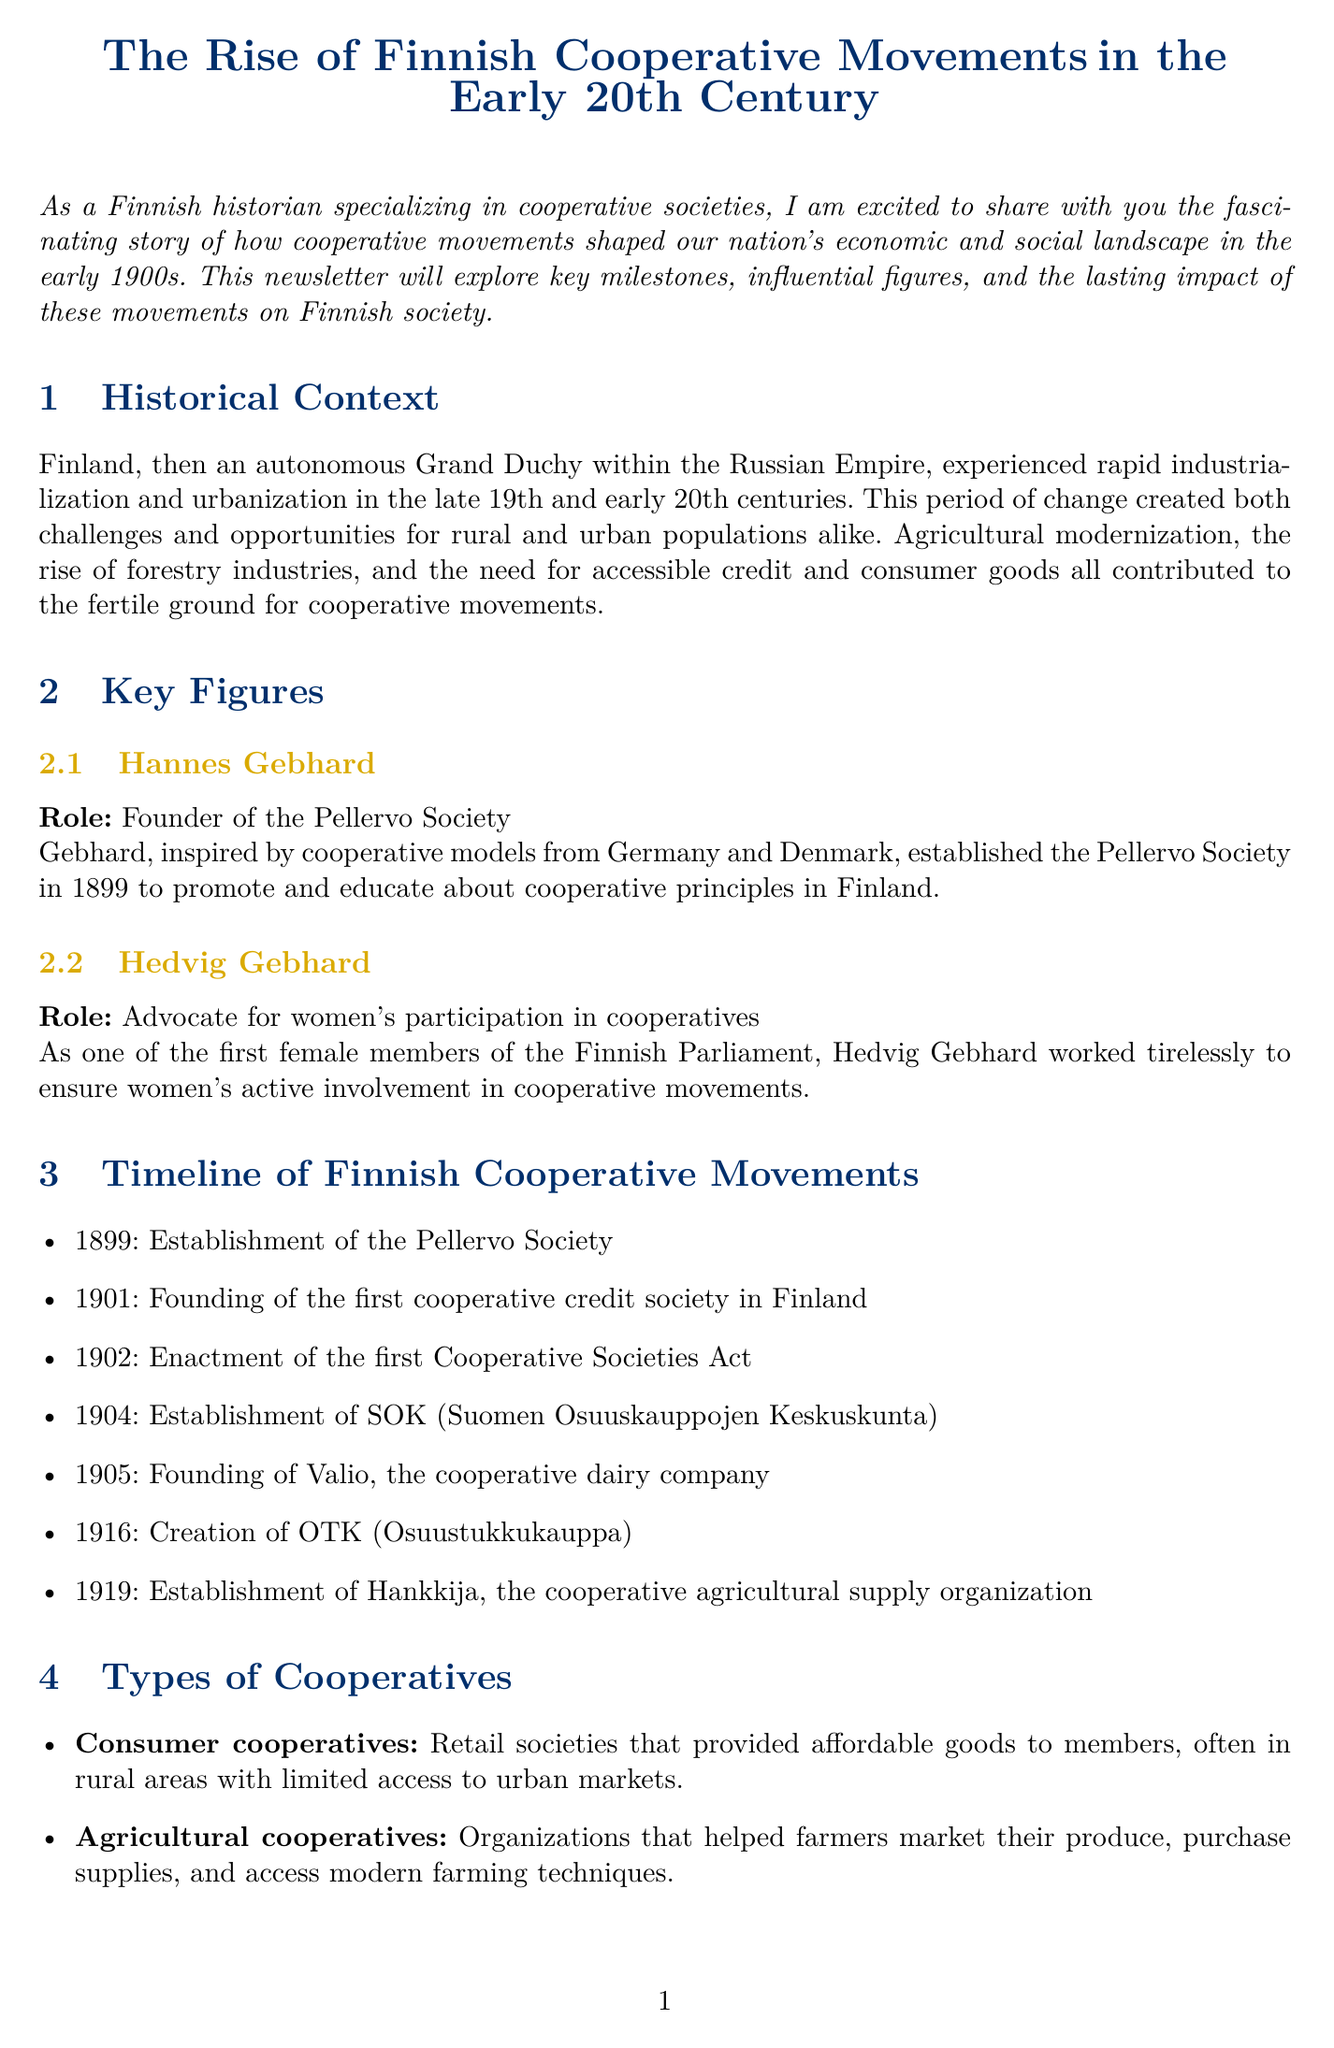What year was the Pellervo Society established? The Pellervo Society was established in the year 1899, as noted in the timeline section of the document.
Answer: 1899 Who founded the Pellervo Society? The timeline and key figures sections of the document mention Hannes Gebhard as the founder of the Pellervo Society.
Answer: Hannes Gebhard What type of cooperative is described as providing affordable goods to members? The types of cooperatives section states that consumer cooperatives are organizations that provide affordable goods to members.
Answer: Consumer cooperatives What significant event occurred in 1902? According to the timeline, the first Cooperative Societies Act was enacted in 1902.
Answer: Enactment of the first Cooperative Societies Act How did cooperatives impact rural living standards? The economic impact analysis explains that cooperatives improved rural living standards by helping small farmers compete with larger estates.
Answer: Improved rural living standards Which individual advocated for women's participation in cooperatives? The key figures section highlights Hedvig Gebhard as an advocate for women's participation in cooperatives.
Answer: Hedvig Gebhard What was the first cooperative credit society established in Finland? The timeline specifies that the first cooperative credit society was founded in the year 1901.
Answer: First cooperative credit society What organization was established in 1916? The timeline lists OTK (Osuustukkukauppa) as the central organization for progressive cooperative societies established in 1916.
Answer: OTK (Osuustukkukauppa) What is the social impact of cooperatives mentioned in the document? The social impact analysis indicates that cooperatives fostered a sense of community and mutual aid, contributing to civil society development in Finland.
Answer: Fostering a sense of community and mutual aid 